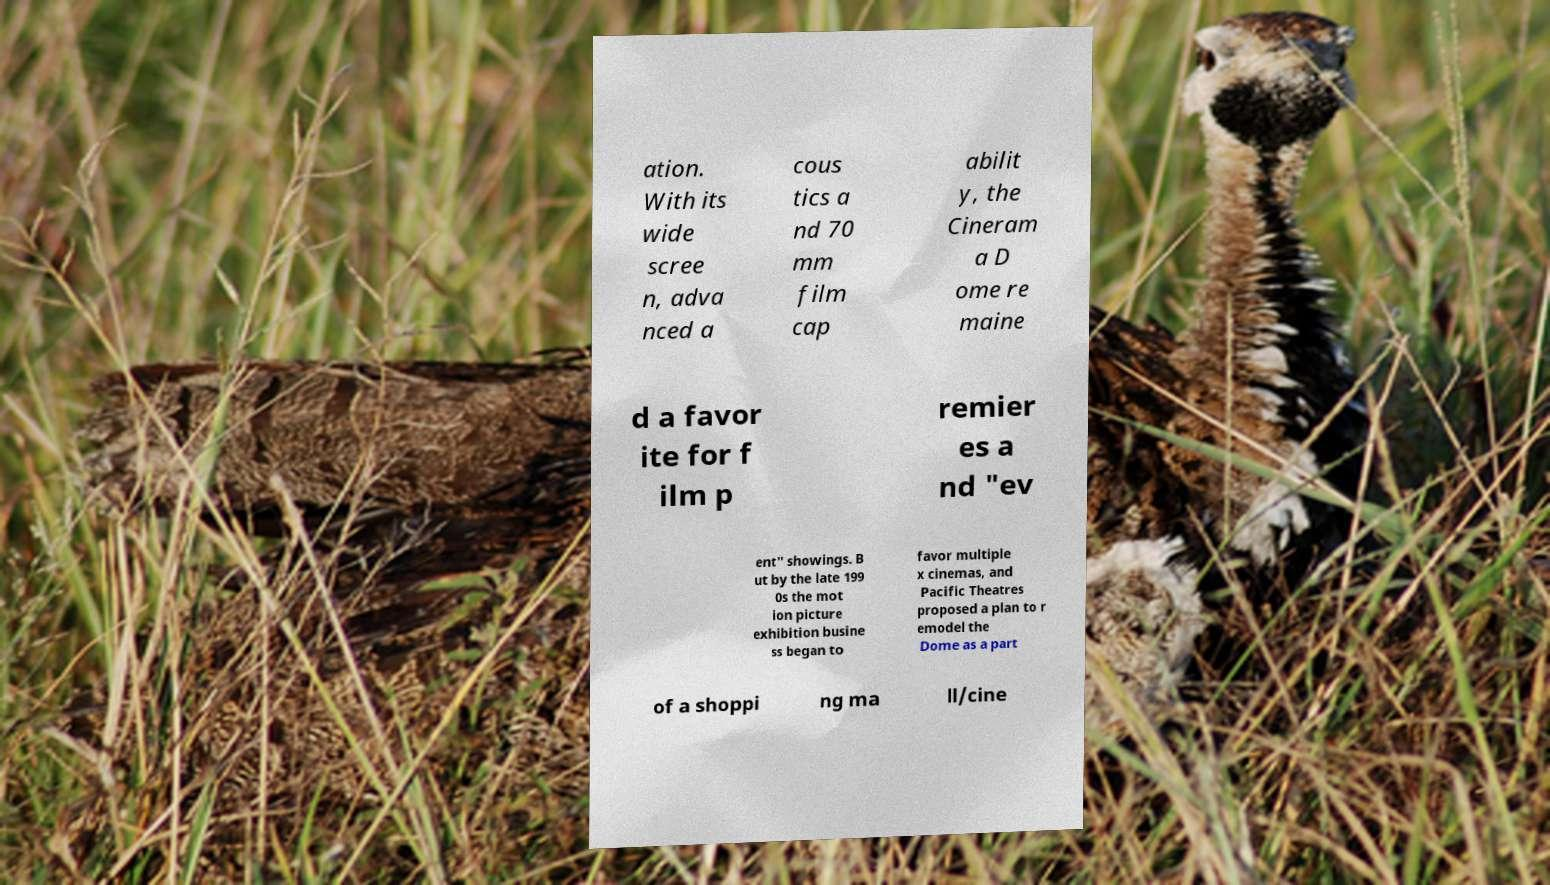Please read and relay the text visible in this image. What does it say? ation. With its wide scree n, adva nced a cous tics a nd 70 mm film cap abilit y, the Cineram a D ome re maine d a favor ite for f ilm p remier es a nd "ev ent" showings. B ut by the late 199 0s the mot ion picture exhibition busine ss began to favor multiple x cinemas, and Pacific Theatres proposed a plan to r emodel the Dome as a part of a shoppi ng ma ll/cine 